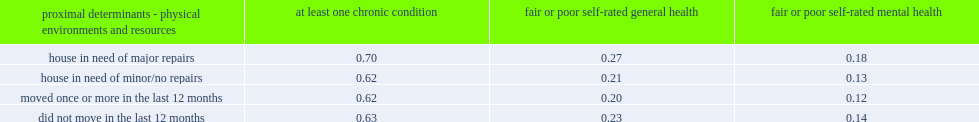What was the proportion of people who reported living in a house where major repairs were needed reported to have at least one chronic condition? 0.7. What was the proportion of people who reported living in a house where minor or no repairs were needed reported to have at least one chronic condition? 0.62. Which physical environment had a higher proportion of people that reported having at least one chronic condition? House in need of major repairs. What was the proportion of people who reported living in a house where major repairs were needed reported to have fair or poor self-rated general health? 0.27. What was the proportion of people who reported living in a house where minor or no repairs were needed reported to have fair or poor self-rated general health? 0.21. Which physical environment had a higher proportion of people that reported fair or poor self-rated general heath? House in need of major repairs. What was the proportion of people who reported living in a house where major repairs were needed reported to have fair or poor self-rated mental health? 0.18. What was the proportion of people who reported living in a house where minor or no repairs were needed reported to have fair or poor self-rated mental health? 0.13. Which physical environment had a higher proportion of people that reported fair or poor self-rated mental heath? House in need of major repairs. What was the proportion of people who moved once or more in the last 12 months reported to have at least one chronic condition? 0.62. What was the proportion of people who moved once or more in the last 12 months reported to have fair or poor self-rated mental health? 0.12. What was the proportion of people who did not move in the last 12 months reported to have fair or poor self-rated mental health? 0.14. Help me parse the entirety of this table. {'header': ['proximal determinants - physical environments and resources', 'at least one chronic condition', 'fair or poor self-rated general health', 'fair or poor self-rated mental health'], 'rows': [['house in need of major repairs', '0.70', '0.27', '0.18'], ['house in need of minor/no repairs', '0.62', '0.21', '0.13'], ['moved once or more in the last 12 months', '0.62', '0.20', '0.12'], ['did not move in the last 12 months', '0.63', '0.23', '0.14']]} 